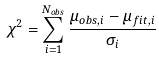<formula> <loc_0><loc_0><loc_500><loc_500>\chi ^ { 2 } = \sum _ { i = 1 } ^ { N _ { o b s } } \frac { \mu _ { o b s , i } - \mu _ { f i t , i } } { \sigma _ { i } }</formula> 